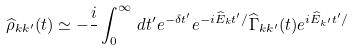<formula> <loc_0><loc_0><loc_500><loc_500>\widehat { \rho } _ { { k } { k } ^ { \prime } } ( t ) \simeq - \frac { i } { } \int _ { 0 } ^ { \infty } \, d t ^ { \prime } e ^ { - \delta t ^ { \prime } } e ^ { - i \widehat { E } _ { k } t ^ { \prime } / } \widehat { \Gamma } _ { { k } { k } ^ { \prime } } ( t ) e ^ { i \widehat { E } _ { { k } ^ { \prime } } t ^ { \prime } / }</formula> 